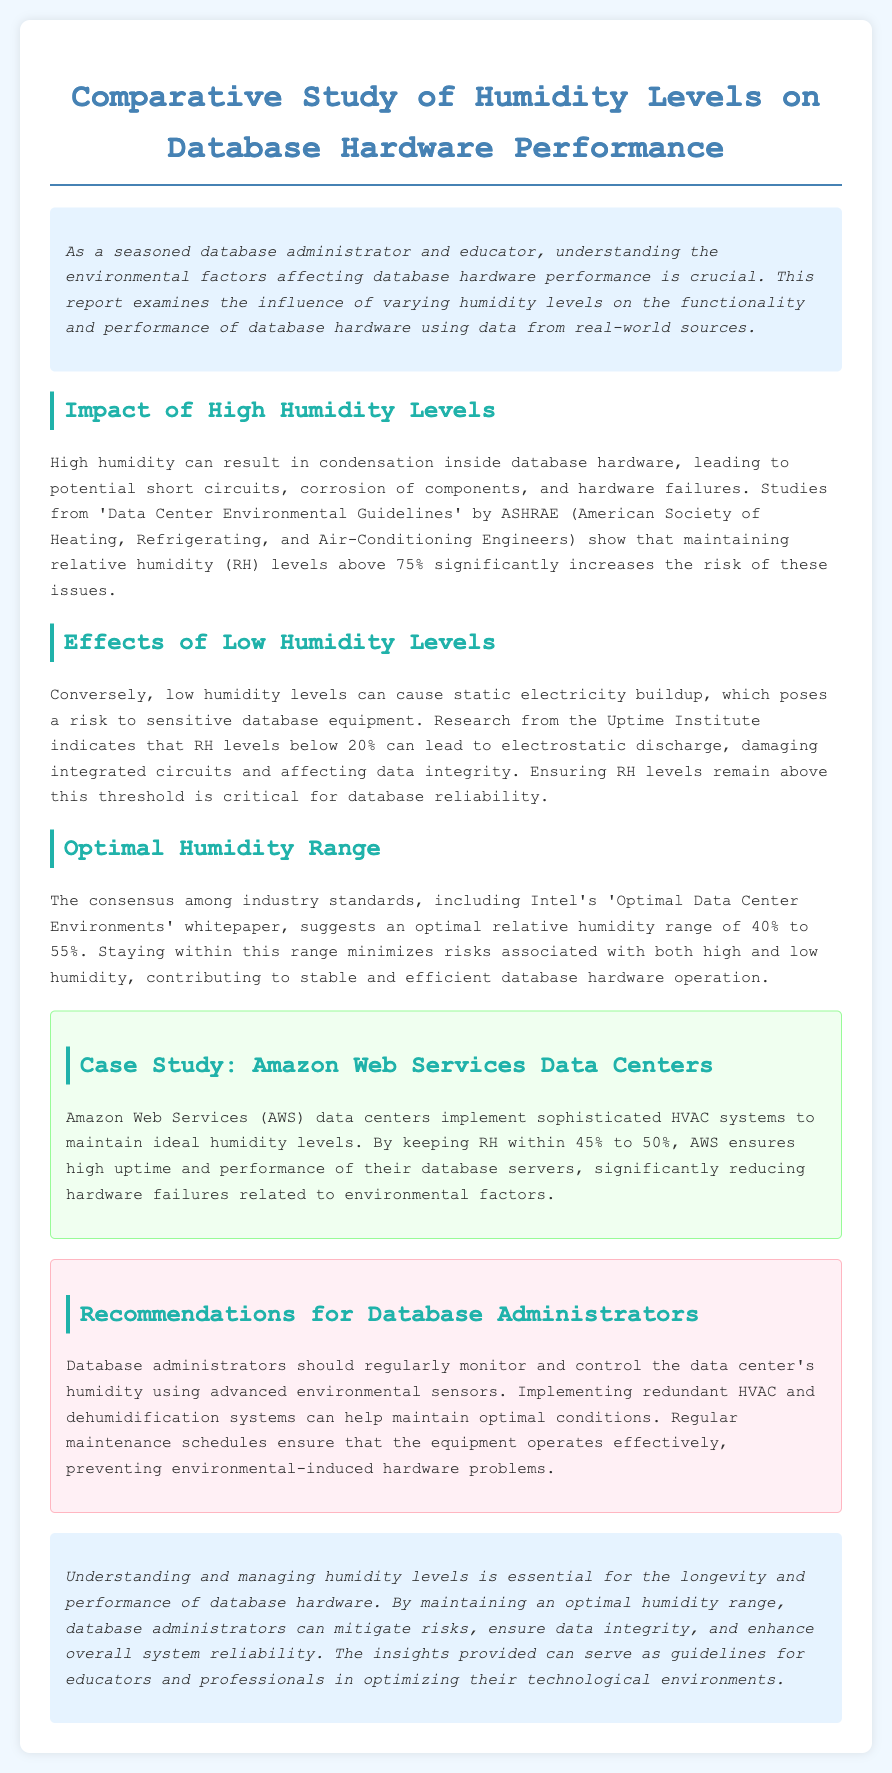What is the introduction about? The introduction discusses the importance of understanding environmental factors affecting database hardware performance and the examination of humidity levels.
Answer: Understanding environmental factors affecting database hardware performance What humidity level increases the risk of hardware failures? The document states that maintaining relative humidity above 75% significantly increases the risk of issues like short circuits and corrosion.
Answer: Above 75% What is the risk associated with humidity levels below 20%? It indicates that levels below 20% can lead to electrostatic discharge, damaging integrated circuits.
Answer: Electrostatic discharge What is the optimal humidity range suggested by industry standards? The consensus suggests an optimal relative humidity range of 40% to 55%.
Answer: 40% to 55% What HVAC strategy does AWS use to maintain humidity levels? AWS implements sophisticated HVAC systems to maintain ideal humidity levels.
Answer: Sophisticated HVAC systems Why should database administrators monitor humidity levels? They should monitor humidity levels to ensure optimal conditions and prevent environmental-induced hardware problems.
Answer: Prevent environmental-induced hardware problems What happens when the humidity level is too high? High humidity can lead to condensation, resulting in potential short circuits and corrosion of components.
Answer: Condensation, short circuits, corrosion What percentage of relative humidity does AWS maintain? AWS keeps relative humidity within 45% to 50%.
Answer: 45% to 50% 